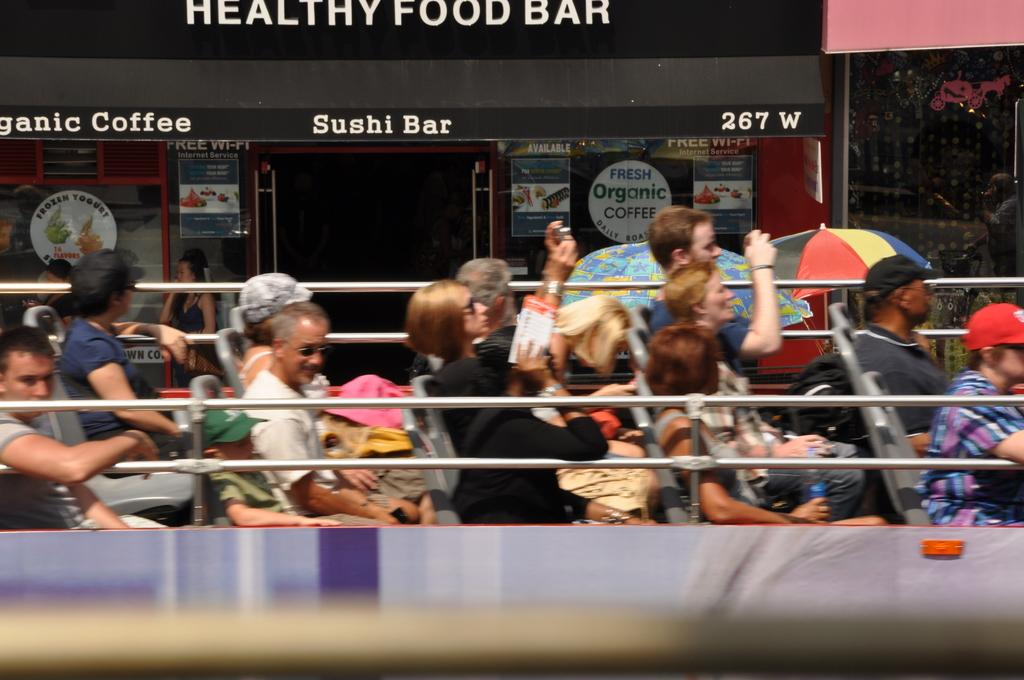Who is present in the image? There are people in the image. What are the people doing in the image? The people are sitting in a swing. What else can be seen in the image besides the people? There is a food bar in the image. What type of pot can be seen in the image? There is no pot present in the image. What news is being reported in the image? There is no news or news reporting present in the image. 